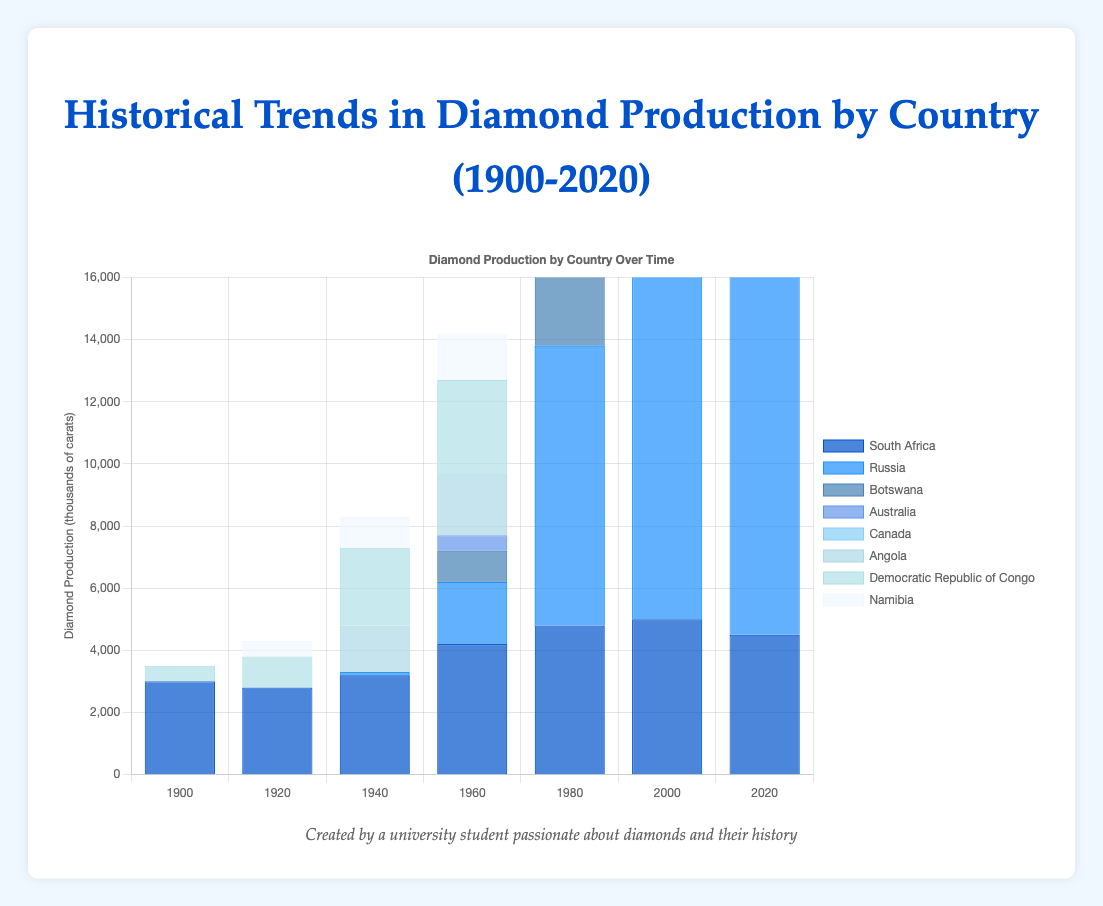Which country had the highest diamond production in 2020? To find the highest production in 2020, compare the production values of all the countries listed for that year. Russia has the highest value with 15,000 thousand carats.
Answer: Russia Which country showed a constant increase in diamond production from 1940 to 2020? Look at the individual country trends over time. Russia showed a consistent increase in production through all the years from 1940 to 2020.
Answer: Russia How does South Africa's production in 2000 compare to Angola's production in 2020? Compare the production values of South Africa in 2000 and Angola in 2020. South Africa's production was 5000 thousand carats in 2000, while Angola's production was 3000 thousand carats in 2020. South Africa's production in 2000 was higher.
Answer: South Africa's 2000 production is higher What is the total diamond production of Canada from 2000 to 2020? Sum the production values of Canada for the years 2000 and 2020. 3000 + 4000 = 7000 thousand carats.
Answer: 7000 thousand carats Which country had the largest decrease in production from 2000 to 2020? Calculate the difference in production values for each country from 2000 to 2020 and find the one with the largest decrease. Australia's production decreased from 4200 to 1000, a decrease of 3200 thousand carats, which is the largest.
Answer: Australia Among South Africa, Botswana, and Angola, which country had the highest drop in production from its peak to 2020? Identify the peak production year and its value for each country, then find the difference between that peak and the 2020 value. South Africa's peak was 5000 in 2000 with a drop of 500 (5000 – 4500); Botswana's peak was 9000 in 2020 with no drop; Angola's peak was 5000 in 2000 with a drop of 2000 (5000 – 3000). The largest drop is Angola's 2000 to 2020 values.
Answer: Angola Which country had no diamond production before 1980 but showed significant production afterward? Identify the countries with zero productions before 1980 and then had significant production in subsequent years. Canada had no production before 1980 and then 3000 in 2000 and 4000 in 2020.
Answer: Canada What is the average diamond production of Botswana from 1960 to 2020? Sum Botswana’s production values from 1960, 1980, 2000, and 2020, then divide by the number of years. (1000 + 6000 + 8500 + 9000) = 24500; average = 24500/4 = 6125 thousand carats.
Answer: 6125 thousand carats Which country had the highest production in 1980 and how does it compare to South Africa’s production of the same year? Identify the country with the highest production in 1980 and compare its value with South Africa's production in that year. Russia had the highest value in 1980 with 9000 thousand carats, while South Africa produced 4800 thousand carats. Russia's production in 1980 was higher.
Answer: Russia Between South Africa and the Democratic Republic of Congo, which one had a more stable production trend from 1900 to 2020? Analyze the production trends for both countries. South Africa's production varies between 2800 and 5000, showing more fluctuations. The Democratic Republic of Congo's production increased steadily to peak in 1980 at 4000 and decreased gradually, indicating a more stable trend.
Answer: Democratic Republic of Congo 